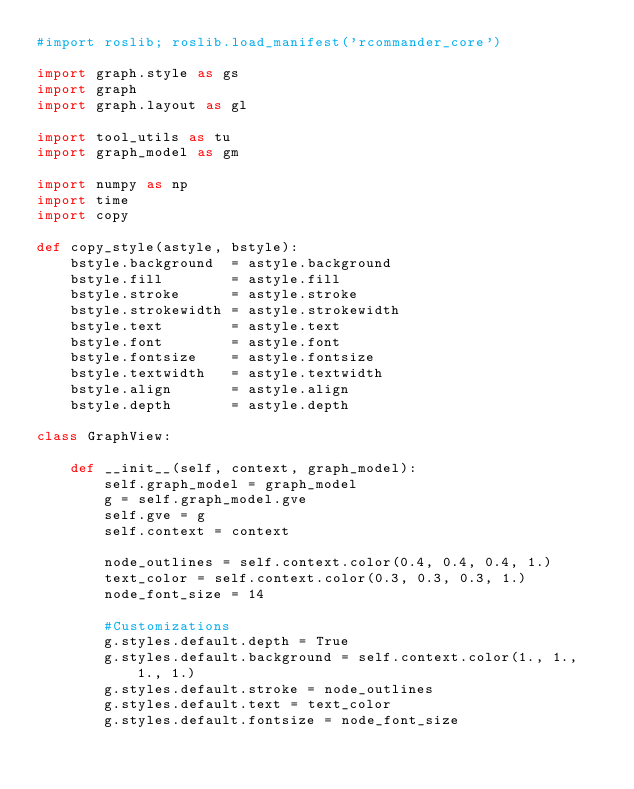Convert code to text. <code><loc_0><loc_0><loc_500><loc_500><_Python_>#import roslib; roslib.load_manifest('rcommander_core')

import graph.style as gs
import graph
import graph.layout as gl

import tool_utils as tu
import graph_model as gm

import numpy as np
import time
import copy

def copy_style(astyle, bstyle):
    bstyle.background  = astyle.background  
    bstyle.fill        = astyle.fill       
    bstyle.stroke      = astyle.stroke     
    bstyle.strokewidth = astyle.strokewidth
    bstyle.text        = astyle.text       
    bstyle.font        = astyle.font       
    bstyle.fontsize    = astyle.fontsize   
    bstyle.textwidth   = astyle.textwidth  
    bstyle.align       = astyle.align      
    bstyle.depth       = astyle.depth      

class GraphView:

    def __init__(self, context, graph_model):
        self.graph_model = graph_model
        g = self.graph_model.gve
        self.gve = g
        self.context = context 

        node_outlines = self.context.color(0.4, 0.4, 0.4, 1.)
        text_color = self.context.color(0.3, 0.3, 0.3, 1.)
        node_font_size = 14

        #Customizations
        g.styles.default.depth = True
        g.styles.default.background = self.context.color(1., 1., 1., 1.)
        g.styles.default.stroke = node_outlines
        g.styles.default.text = text_color
        g.styles.default.fontsize = node_font_size</code> 